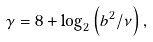Convert formula to latex. <formula><loc_0><loc_0><loc_500><loc_500>\gamma = 8 + \log _ { 2 } \left ( b ^ { 2 } / \nu \right ) ,</formula> 